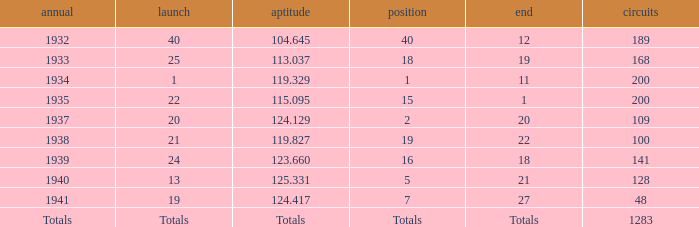What year did he start at 13? 1940.0. 